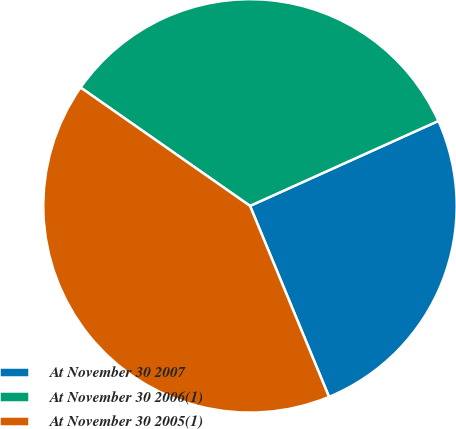<chart> <loc_0><loc_0><loc_500><loc_500><pie_chart><fcel>At November 30 2007<fcel>At November 30 2006(1)<fcel>At November 30 2005(1)<nl><fcel>25.5%<fcel>33.55%<fcel>40.95%<nl></chart> 